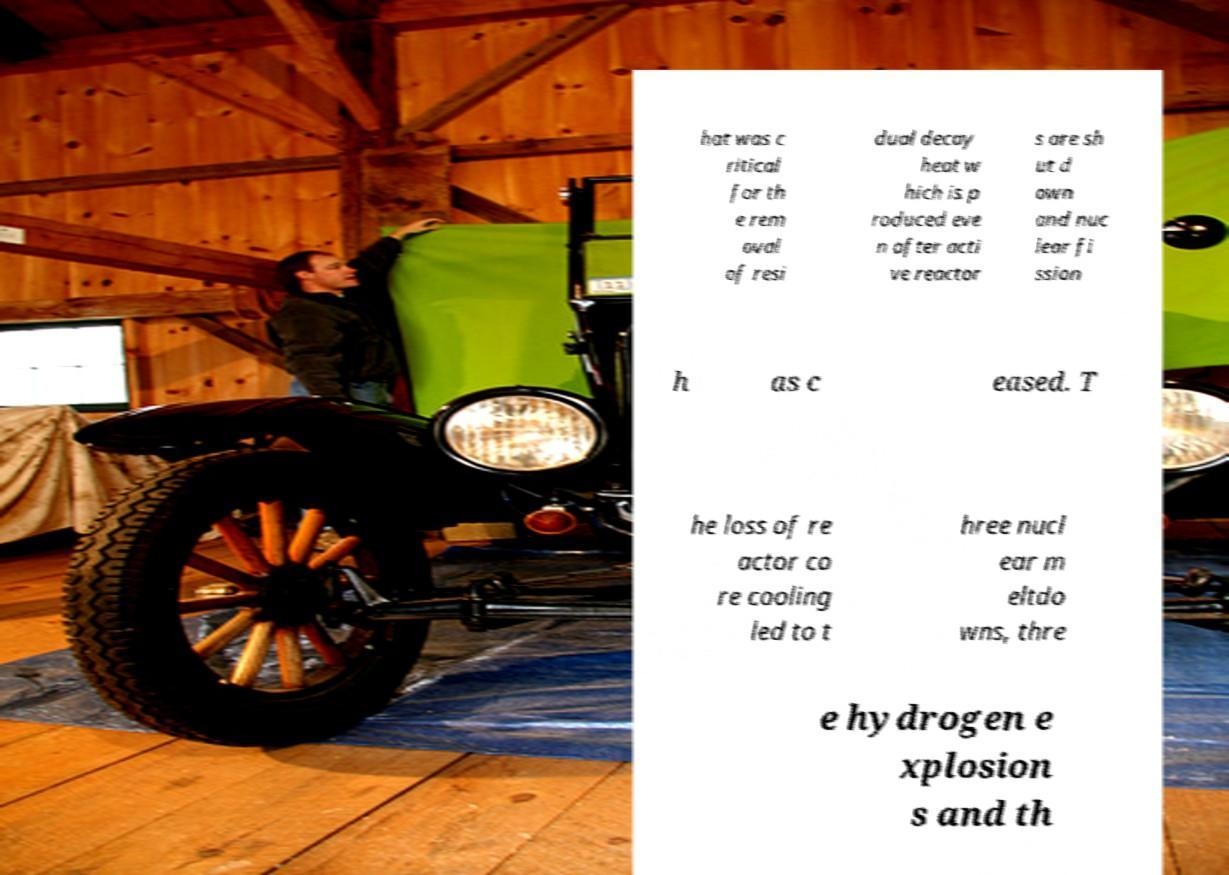What messages or text are displayed in this image? I need them in a readable, typed format. hat was c ritical for th e rem oval of resi dual decay heat w hich is p roduced eve n after acti ve reactor s are sh ut d own and nuc lear fi ssion h as c eased. T he loss of re actor co re cooling led to t hree nucl ear m eltdo wns, thre e hydrogen e xplosion s and th 